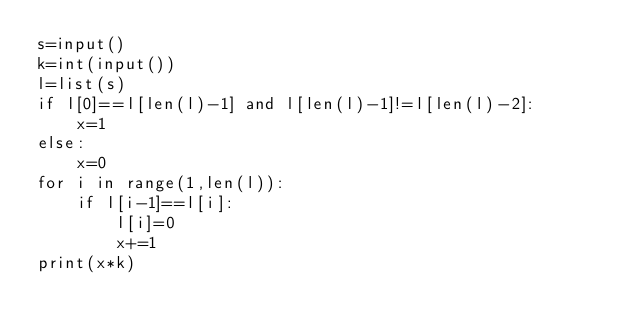<code> <loc_0><loc_0><loc_500><loc_500><_Python_>s=input()
k=int(input())
l=list(s)
if l[0]==l[len(l)-1] and l[len(l)-1]!=l[len(l)-2]:
    x=1
else:
    x=0
for i in range(1,len(l)):
    if l[i-1]==l[i]:
        l[i]=0
        x+=1
print(x*k)
</code> 